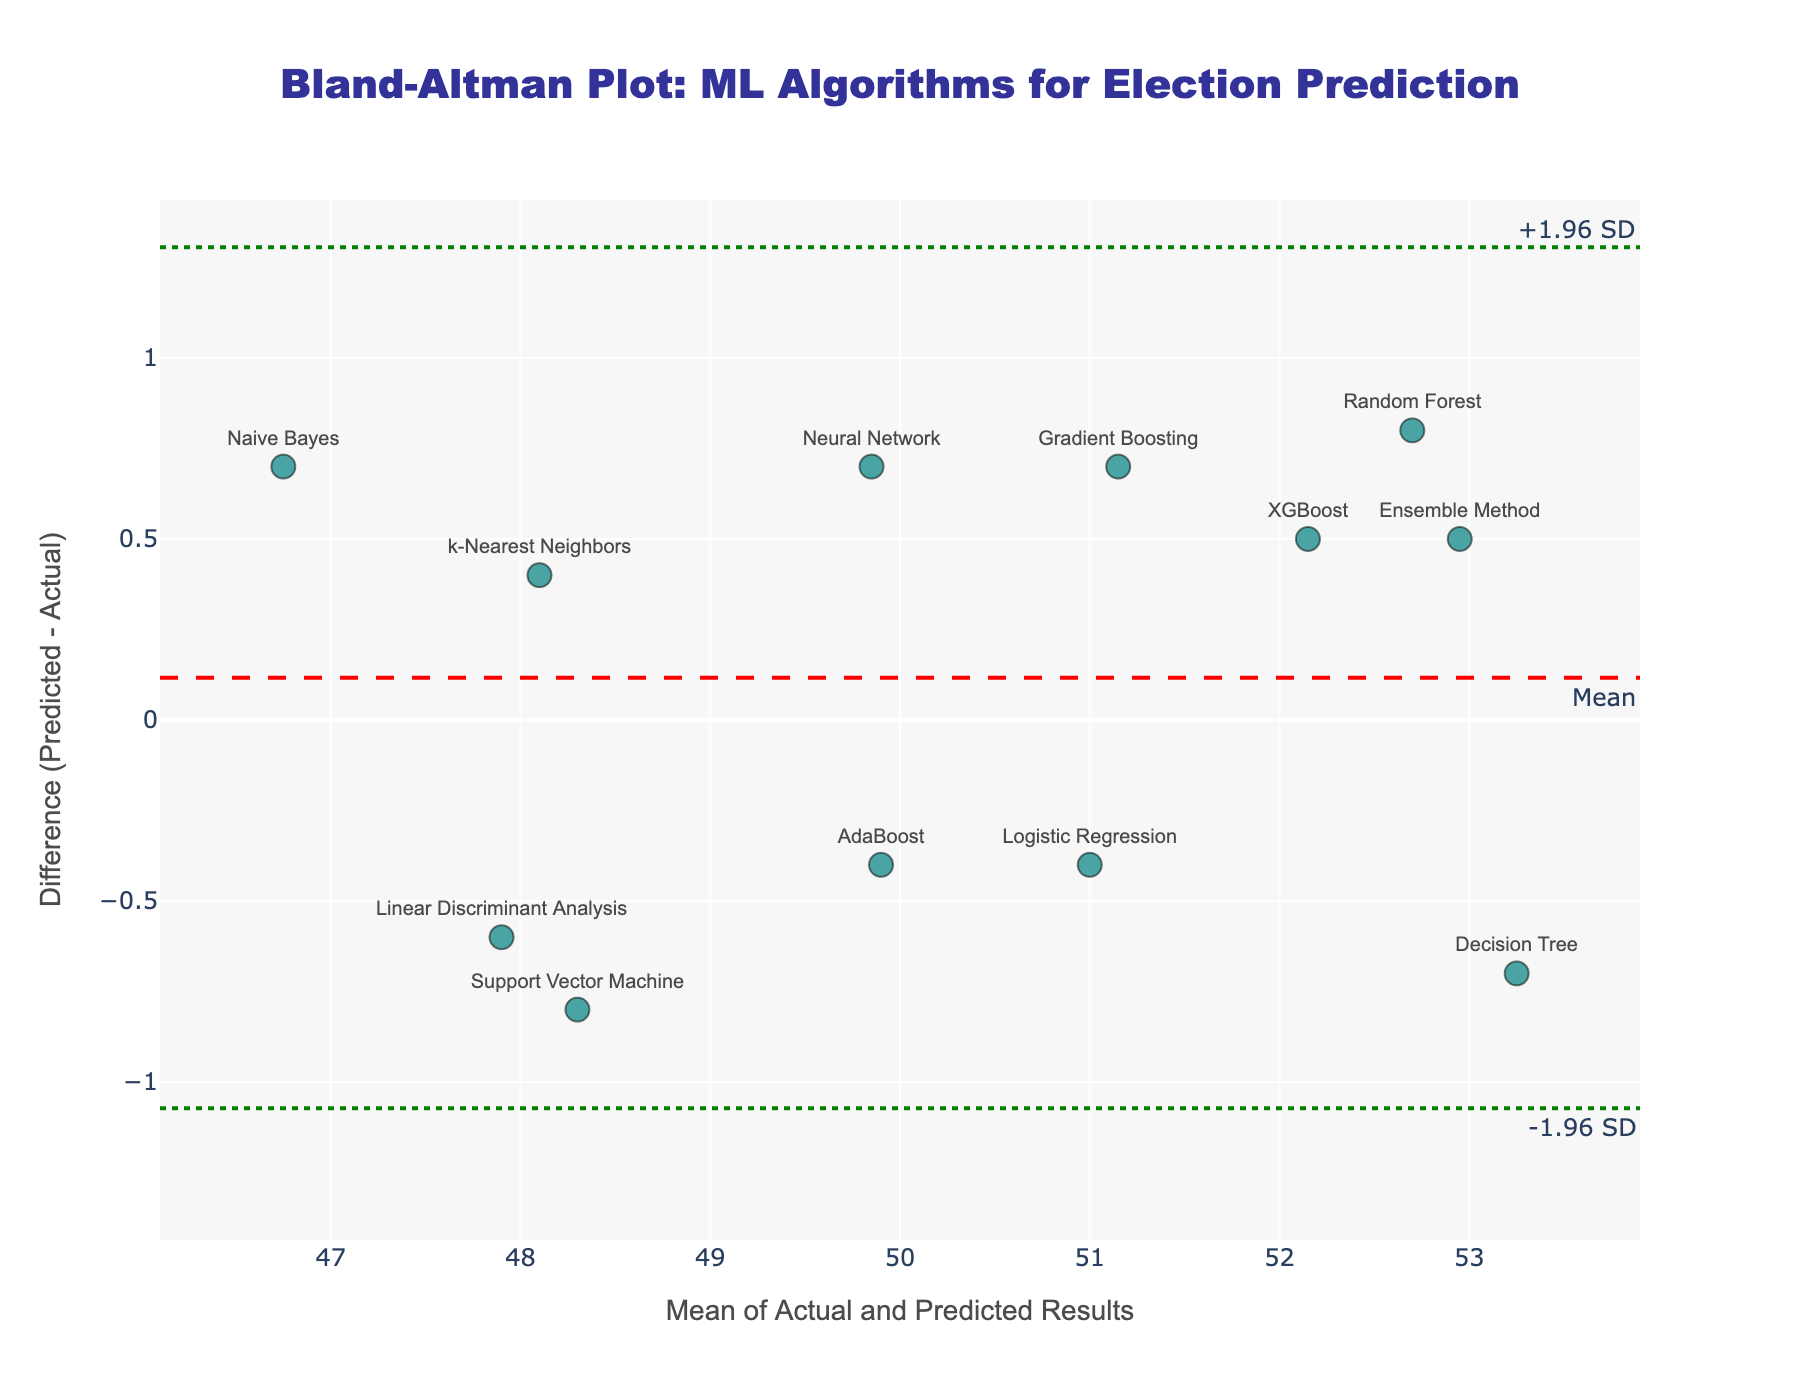How many different algorithms are compared in the Bland-Altman plot? Count the number of different labeled data points shown in the plot. Each point corresponds to a different algorithm.
Answer: 12 What is the title of the Bland-Altman plot? Look at the text displayed at the top of the plot.
Answer: Bland-Altman Plot: ML Algorithms for Election Prediction What is the general range of the x-axis in the Bland-Altman plot? Observe the x-axis scale to determine the minimum and maximum values.
Answer: Approximately 47 to 54 Which algorithm has the largest positive difference between predicted and actual results? Identify the data point farthest above the zero line and read its label.
Answer: Random Forest What is the y-value of the mean difference line? Look for the red dashed line labeled "Mean" and note its y-intercept.
Answer: 0 How many algorithms fall within the limits of agreement (between +1.96 SD and -1.96 SD)? Count the number of data points that lie between the two green dotted lines on the y-axis.
Answer: 12 Which algorithms have predicted results higher than their actual results? Analyze which points lie above the zero line (positive y-values) and note their corresponding labels.
Answer: Random Forest, Neural Network, Gradient Boosting, k-Nearest Neighbors, Naive Bayes, XGBoost, Ensemble Method What is the upper limit of agreement (upper green dotted line)? Observe the y-value of the top green dotted line labeled "+1.96 SD".
Answer: Approximately 1.14 Is the prediction error generally symmetrical around the mean? Compare the distribution of points above and below the red dashed mean line.
Answer: Yes What is the range of differences in predicted and actual results? Find the highest and lowest y-values (differences) plotted and calculate the range by subtracting the smallest value from the largest value.
Answer: Approximately -1.2 to 1 (range: about 2.2) 